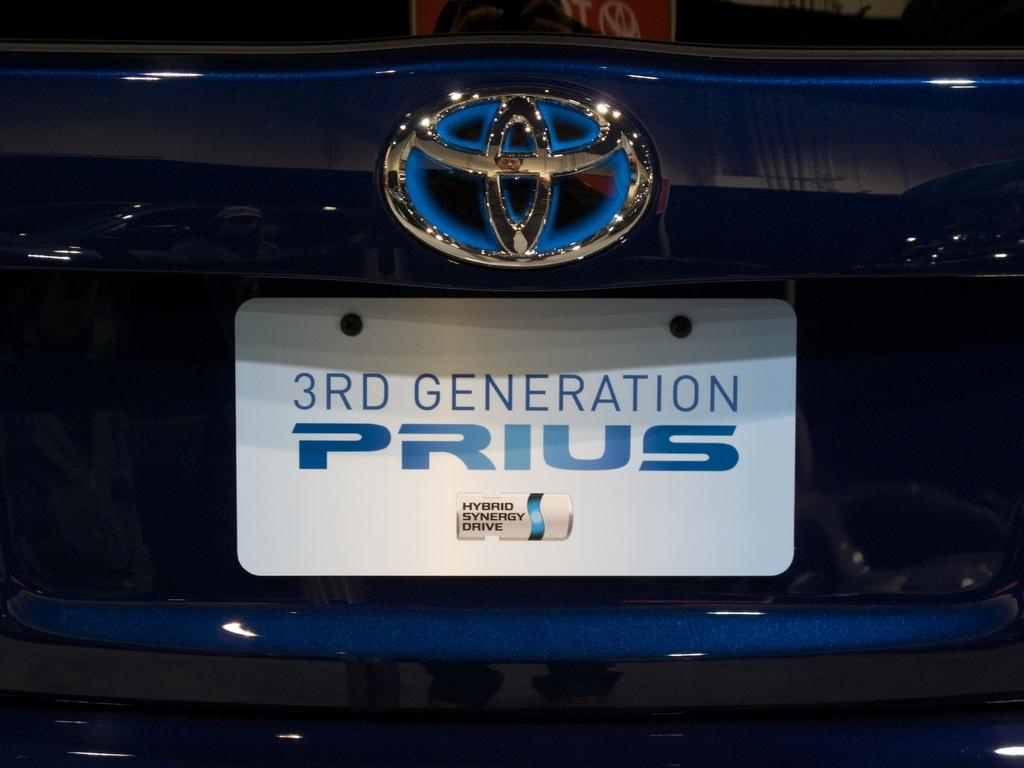What is the main subject of the image? The main subject of the image is a car. Are there any distinguishing features on the car? Yes, there is a logo on the car. What else can be seen on the car? There is a number plate on the car. Can you describe the number plate? The number plate has text on it. What type of company is associated with the rail on the car in the image? There is no rail present on the car in the image. How many letters are visible on the letters in the image? There are no letters present in the image. 